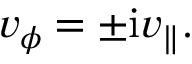<formula> <loc_0><loc_0><loc_500><loc_500>v _ { \phi } = \pm i v _ { \| } .</formula> 